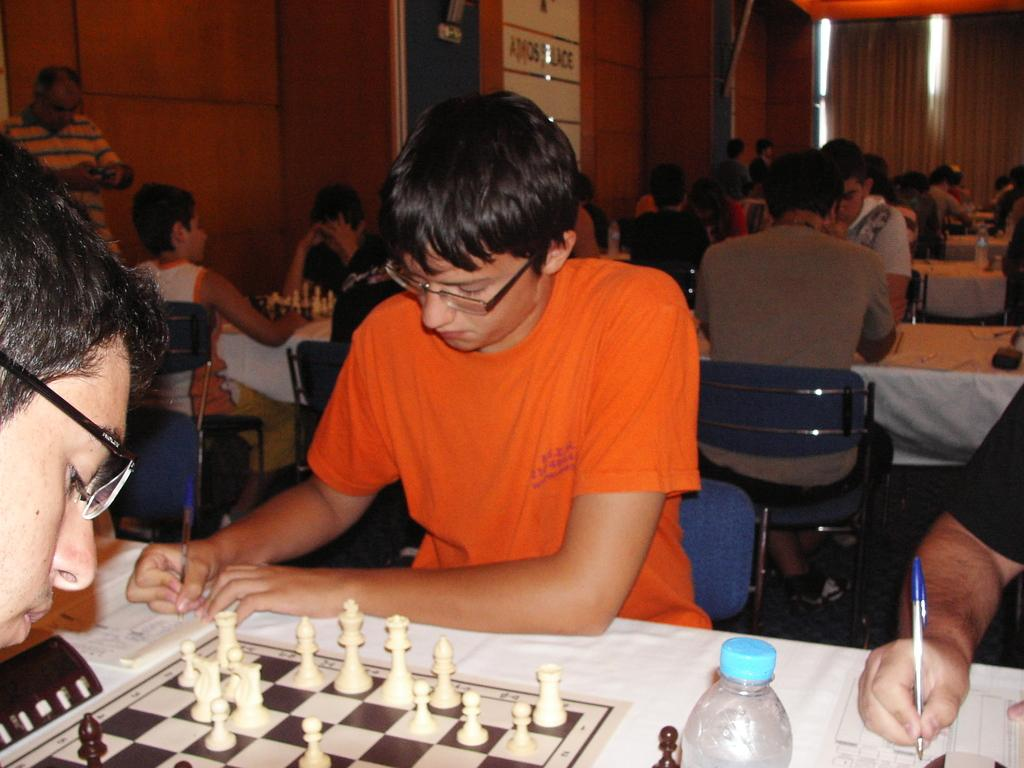What are the persons in the image doing while sitting on chairs? The persons are writing while sitting on chairs. What objects are the persons holding in their hands? The persons are holding pens in their hands. What is present on the table in the image? There is a bottle and chess pieces on the table. What type of magic is being performed by the persons in the image? There is no indication of magic being performed in the image; the persons are writing with pens. How many teeth can be seen in the mouth of the person in the image? There is no person's mouth visible in the image, so it is not possible to determine the number of teeth. 